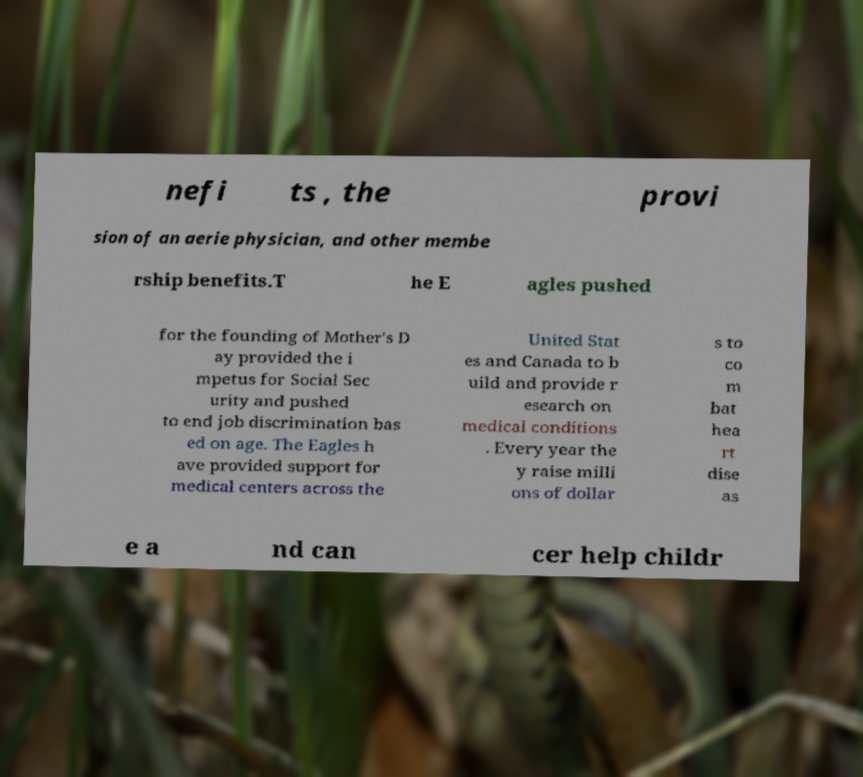For documentation purposes, I need the text within this image transcribed. Could you provide that? nefi ts , the provi sion of an aerie physician, and other membe rship benefits.T he E agles pushed for the founding of Mother's D ay provided the i mpetus for Social Sec urity and pushed to end job discrimination bas ed on age. The Eagles h ave provided support for medical centers across the United Stat es and Canada to b uild and provide r esearch on medical conditions . Every year the y raise milli ons of dollar s to co m bat hea rt dise as e a nd can cer help childr 